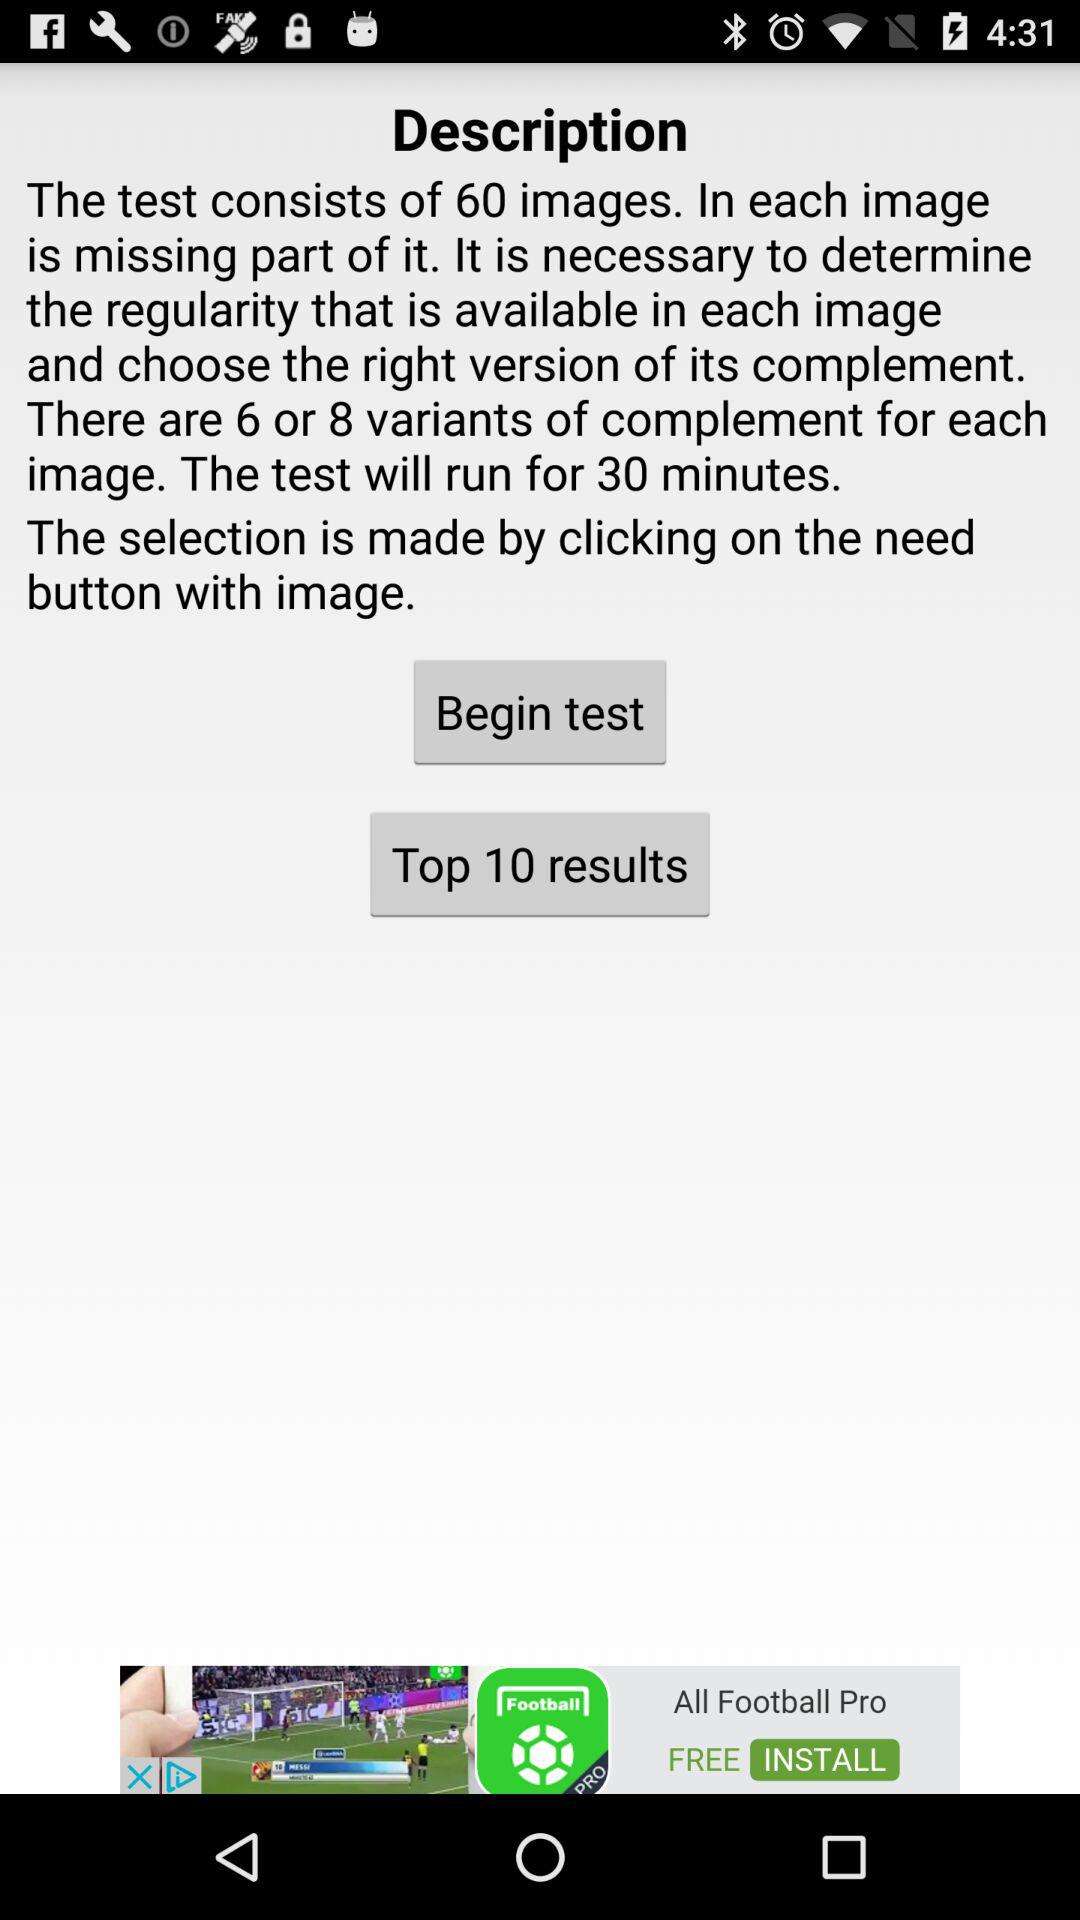What's the duration of the test? The duration is 30 minutes. 